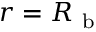<formula> <loc_0><loc_0><loc_500><loc_500>r = R _ { b }</formula> 